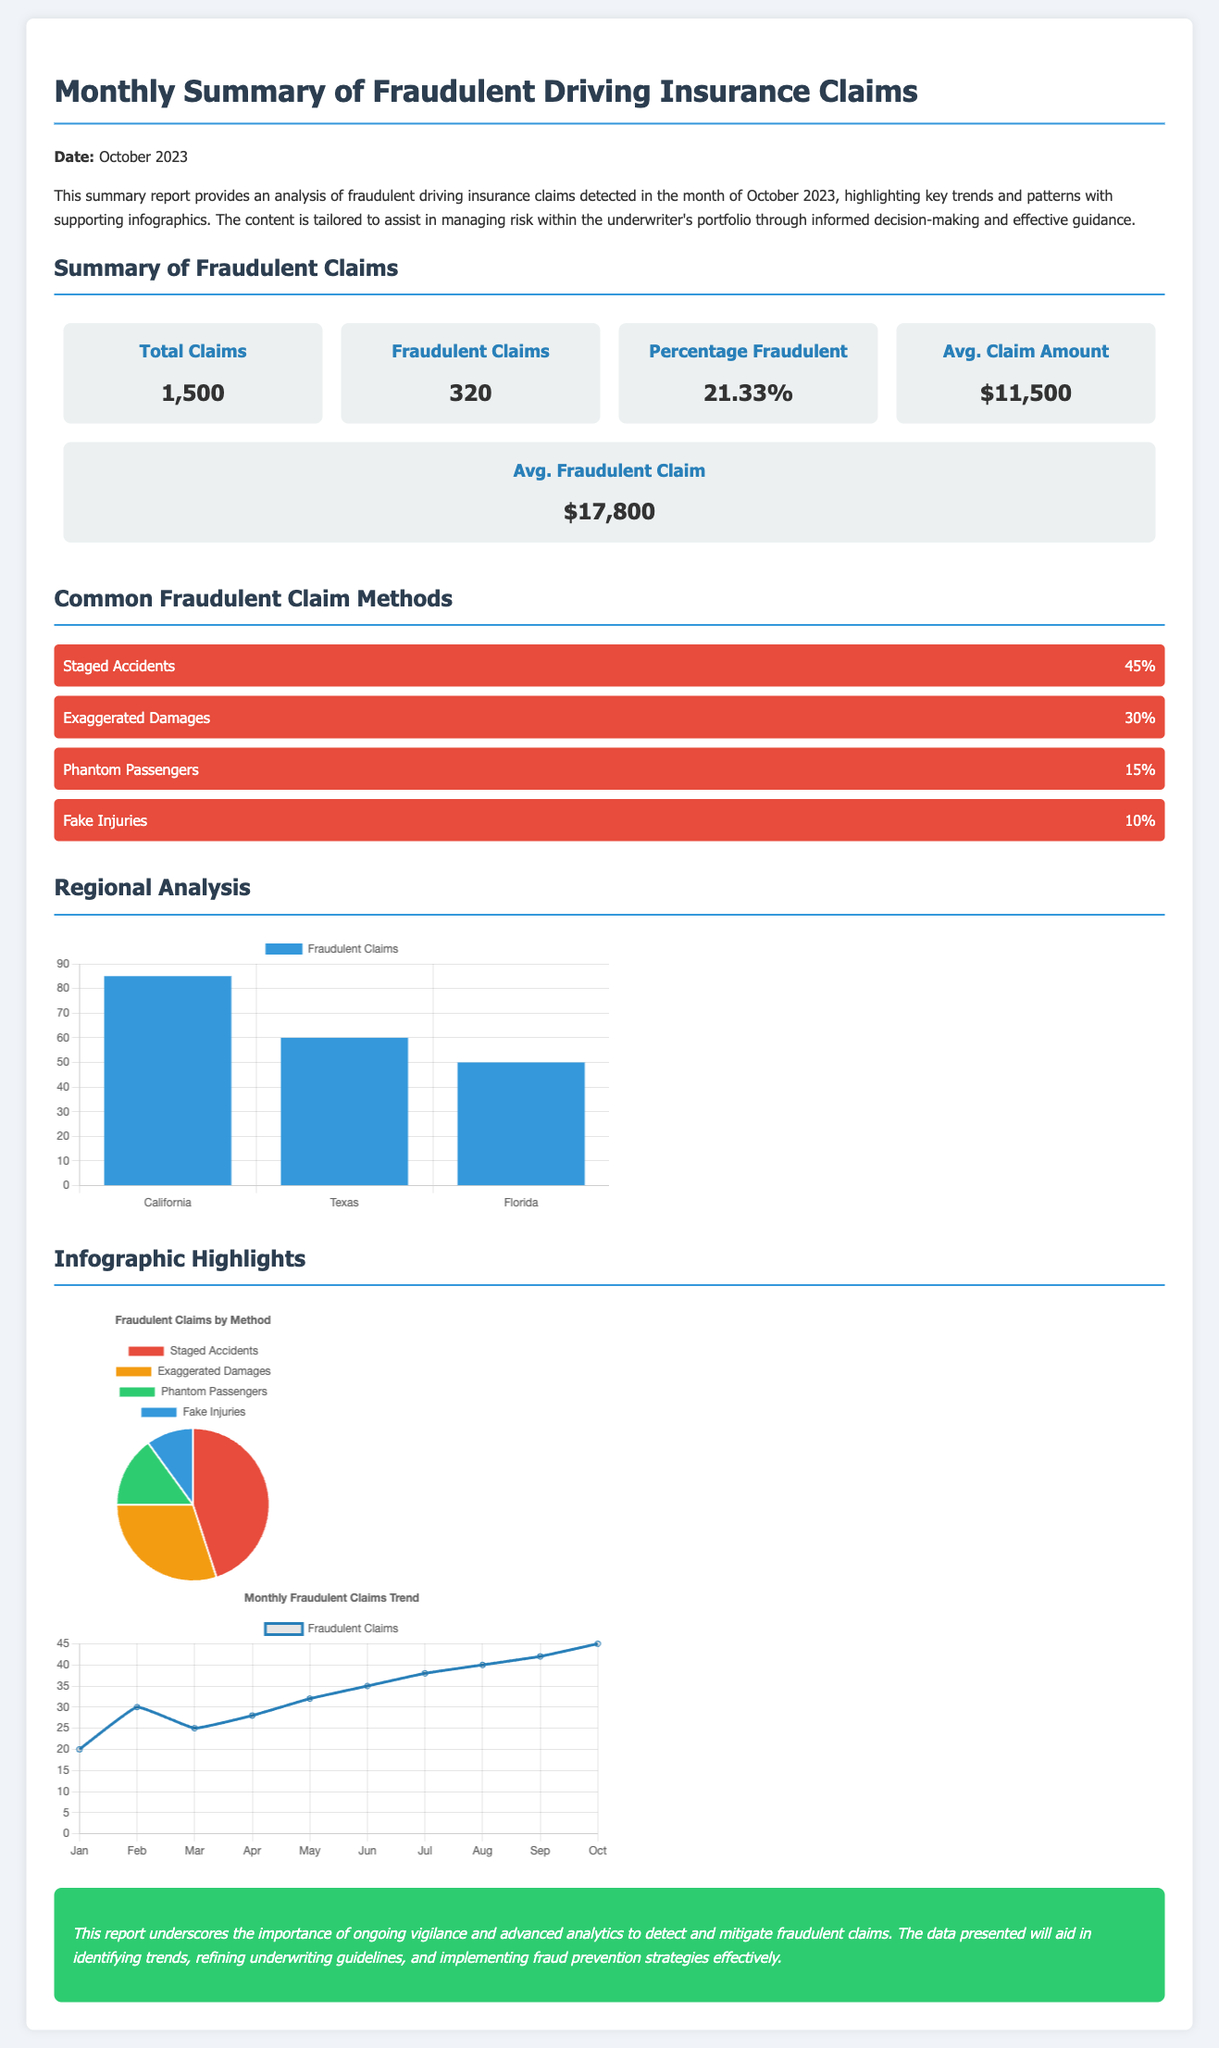What is the total number of claims? The total claims are listed in the summary section as 1,500.
Answer: 1,500 How many claims were identified as fraudulent? The summary indicates that there were 320 fraudulent claims detected.
Answer: 320 What is the percentage of fraudulent claims? The document states that the percentage of fraudulent claims is 21.33%.
Answer: 21.33% What is the average amount for fraudulent claims? The average amount for fraudulent claims is provided as $17,800.
Answer: $17,800 Which method accounts for 45% of fraudulent claims? The report lists "Staged Accidents" as the method accounting for 45% of fraudulent claims.
Answer: Staged Accidents What was the fraudulent claim amount in Texas? In the regional analysis chart, Texas shows 60 fraudulent claims.
Answer: 60 What is the trend in fraudulent claims from January to October? The trend chart indicates a consistent increase in fraudulent claims from January to October.
Answer: Increase Which region had the highest number of fraudulent claims? The regional analysis indicates that California had the highest number of fraudulent claims at 85.
Answer: California What is the average claim amount for all claims? The average claim amount across all claims is listed in the report as $11,500.
Answer: $11,500 